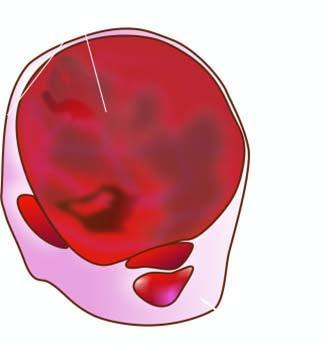s the basement membrane enlarged diffusely?
Answer the question using a single word or phrase. No 